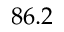Convert formula to latex. <formula><loc_0><loc_0><loc_500><loc_500>8 6 . 2</formula> 